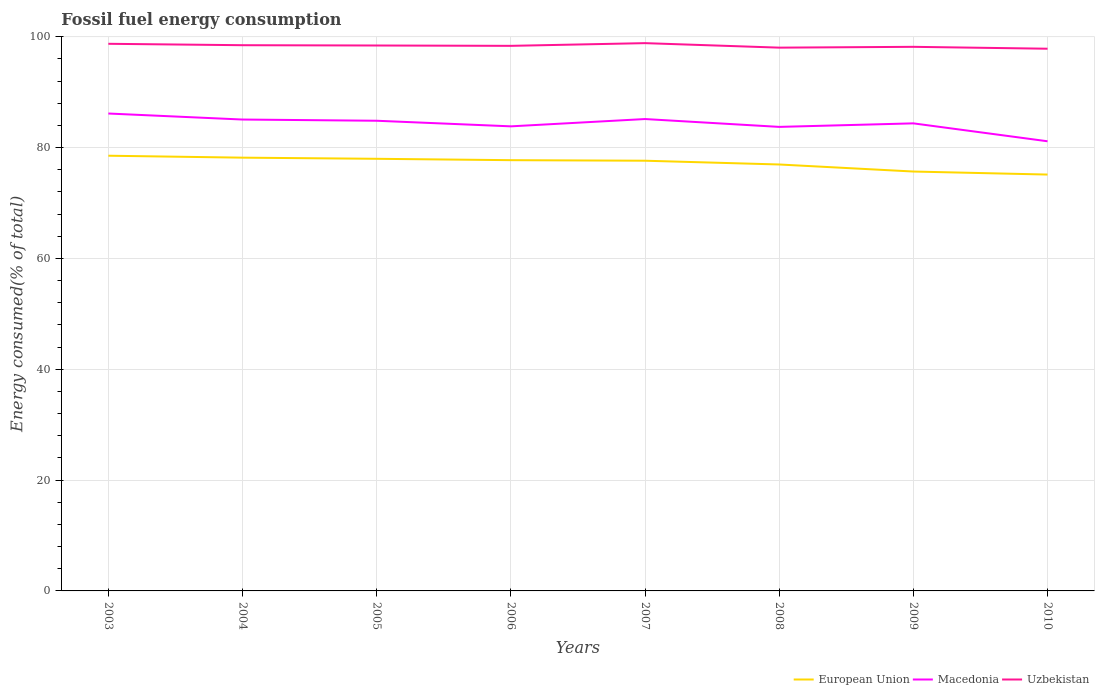How many different coloured lines are there?
Offer a very short reply. 3. Does the line corresponding to European Union intersect with the line corresponding to Uzbekistan?
Provide a succinct answer. No. Across all years, what is the maximum percentage of energy consumed in European Union?
Keep it short and to the point. 75.14. In which year was the percentage of energy consumed in European Union maximum?
Offer a very short reply. 2010. What is the total percentage of energy consumed in European Union in the graph?
Make the answer very short. 2.51. What is the difference between the highest and the second highest percentage of energy consumed in Macedonia?
Your response must be concise. 5.01. What is the difference between the highest and the lowest percentage of energy consumed in European Union?
Your response must be concise. 5. Is the percentage of energy consumed in Macedonia strictly greater than the percentage of energy consumed in European Union over the years?
Your answer should be very brief. No. How many lines are there?
Offer a very short reply. 3. What is the difference between two consecutive major ticks on the Y-axis?
Your answer should be very brief. 20. Does the graph contain grids?
Offer a terse response. Yes. How many legend labels are there?
Ensure brevity in your answer.  3. What is the title of the graph?
Your answer should be very brief. Fossil fuel energy consumption. Does "Middle income" appear as one of the legend labels in the graph?
Make the answer very short. No. What is the label or title of the Y-axis?
Keep it short and to the point. Energy consumed(% of total). What is the Energy consumed(% of total) in European Union in 2003?
Provide a short and direct response. 78.54. What is the Energy consumed(% of total) in Macedonia in 2003?
Make the answer very short. 86.15. What is the Energy consumed(% of total) in Uzbekistan in 2003?
Your answer should be compact. 98.73. What is the Energy consumed(% of total) of European Union in 2004?
Offer a very short reply. 78.19. What is the Energy consumed(% of total) of Macedonia in 2004?
Provide a succinct answer. 85.07. What is the Energy consumed(% of total) of Uzbekistan in 2004?
Your response must be concise. 98.48. What is the Energy consumed(% of total) in European Union in 2005?
Keep it short and to the point. 77.98. What is the Energy consumed(% of total) of Macedonia in 2005?
Your response must be concise. 84.85. What is the Energy consumed(% of total) in Uzbekistan in 2005?
Give a very brief answer. 98.43. What is the Energy consumed(% of total) in European Union in 2006?
Offer a terse response. 77.73. What is the Energy consumed(% of total) of Macedonia in 2006?
Keep it short and to the point. 83.84. What is the Energy consumed(% of total) in Uzbekistan in 2006?
Your response must be concise. 98.37. What is the Energy consumed(% of total) in European Union in 2007?
Ensure brevity in your answer.  77.63. What is the Energy consumed(% of total) in Macedonia in 2007?
Your response must be concise. 85.16. What is the Energy consumed(% of total) of Uzbekistan in 2007?
Offer a terse response. 98.85. What is the Energy consumed(% of total) in European Union in 2008?
Make the answer very short. 76.95. What is the Energy consumed(% of total) in Macedonia in 2008?
Make the answer very short. 83.74. What is the Energy consumed(% of total) of Uzbekistan in 2008?
Ensure brevity in your answer.  98.04. What is the Energy consumed(% of total) in European Union in 2009?
Your answer should be very brief. 75.68. What is the Energy consumed(% of total) of Macedonia in 2009?
Offer a very short reply. 84.38. What is the Energy consumed(% of total) in Uzbekistan in 2009?
Give a very brief answer. 98.19. What is the Energy consumed(% of total) in European Union in 2010?
Make the answer very short. 75.14. What is the Energy consumed(% of total) in Macedonia in 2010?
Make the answer very short. 81.14. What is the Energy consumed(% of total) in Uzbekistan in 2010?
Keep it short and to the point. 97.84. Across all years, what is the maximum Energy consumed(% of total) of European Union?
Your answer should be compact. 78.54. Across all years, what is the maximum Energy consumed(% of total) of Macedonia?
Provide a short and direct response. 86.15. Across all years, what is the maximum Energy consumed(% of total) of Uzbekistan?
Provide a succinct answer. 98.85. Across all years, what is the minimum Energy consumed(% of total) in European Union?
Your answer should be compact. 75.14. Across all years, what is the minimum Energy consumed(% of total) in Macedonia?
Offer a very short reply. 81.14. Across all years, what is the minimum Energy consumed(% of total) in Uzbekistan?
Offer a terse response. 97.84. What is the total Energy consumed(% of total) in European Union in the graph?
Your answer should be very brief. 617.84. What is the total Energy consumed(% of total) in Macedonia in the graph?
Provide a short and direct response. 674.31. What is the total Energy consumed(% of total) of Uzbekistan in the graph?
Make the answer very short. 786.93. What is the difference between the Energy consumed(% of total) of European Union in 2003 and that in 2004?
Your answer should be very brief. 0.35. What is the difference between the Energy consumed(% of total) of Macedonia in 2003 and that in 2004?
Your response must be concise. 1.09. What is the difference between the Energy consumed(% of total) of Uzbekistan in 2003 and that in 2004?
Provide a succinct answer. 0.25. What is the difference between the Energy consumed(% of total) in European Union in 2003 and that in 2005?
Your answer should be very brief. 0.56. What is the difference between the Energy consumed(% of total) of Macedonia in 2003 and that in 2005?
Your response must be concise. 1.31. What is the difference between the Energy consumed(% of total) of Uzbekistan in 2003 and that in 2005?
Make the answer very short. 0.31. What is the difference between the Energy consumed(% of total) of European Union in 2003 and that in 2006?
Your response must be concise. 0.8. What is the difference between the Energy consumed(% of total) in Macedonia in 2003 and that in 2006?
Make the answer very short. 2.32. What is the difference between the Energy consumed(% of total) of Uzbekistan in 2003 and that in 2006?
Your answer should be very brief. 0.37. What is the difference between the Energy consumed(% of total) of European Union in 2003 and that in 2007?
Your answer should be compact. 0.9. What is the difference between the Energy consumed(% of total) of Uzbekistan in 2003 and that in 2007?
Provide a short and direct response. -0.12. What is the difference between the Energy consumed(% of total) in European Union in 2003 and that in 2008?
Your answer should be compact. 1.58. What is the difference between the Energy consumed(% of total) in Macedonia in 2003 and that in 2008?
Provide a succinct answer. 2.41. What is the difference between the Energy consumed(% of total) in Uzbekistan in 2003 and that in 2008?
Your answer should be compact. 0.69. What is the difference between the Energy consumed(% of total) of European Union in 2003 and that in 2009?
Give a very brief answer. 2.85. What is the difference between the Energy consumed(% of total) of Macedonia in 2003 and that in 2009?
Make the answer very short. 1.78. What is the difference between the Energy consumed(% of total) of Uzbekistan in 2003 and that in 2009?
Your answer should be compact. 0.54. What is the difference between the Energy consumed(% of total) of European Union in 2003 and that in 2010?
Make the answer very short. 3.4. What is the difference between the Energy consumed(% of total) in Macedonia in 2003 and that in 2010?
Offer a terse response. 5.01. What is the difference between the Energy consumed(% of total) of Uzbekistan in 2003 and that in 2010?
Ensure brevity in your answer.  0.89. What is the difference between the Energy consumed(% of total) in European Union in 2004 and that in 2005?
Offer a very short reply. 0.21. What is the difference between the Energy consumed(% of total) in Macedonia in 2004 and that in 2005?
Give a very brief answer. 0.22. What is the difference between the Energy consumed(% of total) of Uzbekistan in 2004 and that in 2005?
Your answer should be very brief. 0.05. What is the difference between the Energy consumed(% of total) in European Union in 2004 and that in 2006?
Your response must be concise. 0.45. What is the difference between the Energy consumed(% of total) of Macedonia in 2004 and that in 2006?
Your response must be concise. 1.23. What is the difference between the Energy consumed(% of total) of Uzbekistan in 2004 and that in 2006?
Offer a terse response. 0.11. What is the difference between the Energy consumed(% of total) of European Union in 2004 and that in 2007?
Keep it short and to the point. 0.55. What is the difference between the Energy consumed(% of total) of Macedonia in 2004 and that in 2007?
Keep it short and to the point. -0.09. What is the difference between the Energy consumed(% of total) in Uzbekistan in 2004 and that in 2007?
Provide a short and direct response. -0.37. What is the difference between the Energy consumed(% of total) in European Union in 2004 and that in 2008?
Your answer should be very brief. 1.23. What is the difference between the Energy consumed(% of total) in Macedonia in 2004 and that in 2008?
Ensure brevity in your answer.  1.33. What is the difference between the Energy consumed(% of total) in Uzbekistan in 2004 and that in 2008?
Make the answer very short. 0.44. What is the difference between the Energy consumed(% of total) in European Union in 2004 and that in 2009?
Your answer should be very brief. 2.51. What is the difference between the Energy consumed(% of total) of Macedonia in 2004 and that in 2009?
Provide a succinct answer. 0.69. What is the difference between the Energy consumed(% of total) of Uzbekistan in 2004 and that in 2009?
Offer a very short reply. 0.29. What is the difference between the Energy consumed(% of total) in European Union in 2004 and that in 2010?
Make the answer very short. 3.05. What is the difference between the Energy consumed(% of total) of Macedonia in 2004 and that in 2010?
Your answer should be compact. 3.92. What is the difference between the Energy consumed(% of total) in Uzbekistan in 2004 and that in 2010?
Provide a short and direct response. 0.63. What is the difference between the Energy consumed(% of total) of European Union in 2005 and that in 2006?
Your answer should be very brief. 0.25. What is the difference between the Energy consumed(% of total) of Uzbekistan in 2005 and that in 2006?
Your answer should be very brief. 0.06. What is the difference between the Energy consumed(% of total) of European Union in 2005 and that in 2007?
Provide a short and direct response. 0.34. What is the difference between the Energy consumed(% of total) in Macedonia in 2005 and that in 2007?
Provide a succinct answer. -0.31. What is the difference between the Energy consumed(% of total) in Uzbekistan in 2005 and that in 2007?
Provide a succinct answer. -0.42. What is the difference between the Energy consumed(% of total) in European Union in 2005 and that in 2008?
Your response must be concise. 1.03. What is the difference between the Energy consumed(% of total) in Macedonia in 2005 and that in 2008?
Your answer should be very brief. 1.11. What is the difference between the Energy consumed(% of total) in Uzbekistan in 2005 and that in 2008?
Your response must be concise. 0.39. What is the difference between the Energy consumed(% of total) of European Union in 2005 and that in 2009?
Offer a very short reply. 2.3. What is the difference between the Energy consumed(% of total) in Macedonia in 2005 and that in 2009?
Provide a succinct answer. 0.47. What is the difference between the Energy consumed(% of total) in Uzbekistan in 2005 and that in 2009?
Offer a terse response. 0.24. What is the difference between the Energy consumed(% of total) of European Union in 2005 and that in 2010?
Make the answer very short. 2.84. What is the difference between the Energy consumed(% of total) in Macedonia in 2005 and that in 2010?
Ensure brevity in your answer.  3.7. What is the difference between the Energy consumed(% of total) in Uzbekistan in 2005 and that in 2010?
Your answer should be very brief. 0.58. What is the difference between the Energy consumed(% of total) in European Union in 2006 and that in 2007?
Your answer should be very brief. 0.1. What is the difference between the Energy consumed(% of total) of Macedonia in 2006 and that in 2007?
Offer a very short reply. -1.32. What is the difference between the Energy consumed(% of total) of Uzbekistan in 2006 and that in 2007?
Offer a terse response. -0.49. What is the difference between the Energy consumed(% of total) of European Union in 2006 and that in 2008?
Offer a terse response. 0.78. What is the difference between the Energy consumed(% of total) in Macedonia in 2006 and that in 2008?
Offer a very short reply. 0.1. What is the difference between the Energy consumed(% of total) of Uzbekistan in 2006 and that in 2008?
Ensure brevity in your answer.  0.33. What is the difference between the Energy consumed(% of total) in European Union in 2006 and that in 2009?
Give a very brief answer. 2.05. What is the difference between the Energy consumed(% of total) in Macedonia in 2006 and that in 2009?
Make the answer very short. -0.54. What is the difference between the Energy consumed(% of total) of Uzbekistan in 2006 and that in 2009?
Provide a short and direct response. 0.18. What is the difference between the Energy consumed(% of total) in European Union in 2006 and that in 2010?
Provide a short and direct response. 2.6. What is the difference between the Energy consumed(% of total) of Macedonia in 2006 and that in 2010?
Offer a terse response. 2.69. What is the difference between the Energy consumed(% of total) in Uzbekistan in 2006 and that in 2010?
Make the answer very short. 0.52. What is the difference between the Energy consumed(% of total) of European Union in 2007 and that in 2008?
Make the answer very short. 0.68. What is the difference between the Energy consumed(% of total) of Macedonia in 2007 and that in 2008?
Keep it short and to the point. 1.42. What is the difference between the Energy consumed(% of total) of Uzbekistan in 2007 and that in 2008?
Provide a short and direct response. 0.81. What is the difference between the Energy consumed(% of total) in European Union in 2007 and that in 2009?
Keep it short and to the point. 1.95. What is the difference between the Energy consumed(% of total) of Macedonia in 2007 and that in 2009?
Keep it short and to the point. 0.78. What is the difference between the Energy consumed(% of total) of Uzbekistan in 2007 and that in 2009?
Your response must be concise. 0.66. What is the difference between the Energy consumed(% of total) in European Union in 2007 and that in 2010?
Your response must be concise. 2.5. What is the difference between the Energy consumed(% of total) in Macedonia in 2007 and that in 2010?
Your answer should be compact. 4.01. What is the difference between the Energy consumed(% of total) of Uzbekistan in 2007 and that in 2010?
Your response must be concise. 1.01. What is the difference between the Energy consumed(% of total) in European Union in 2008 and that in 2009?
Ensure brevity in your answer.  1.27. What is the difference between the Energy consumed(% of total) of Macedonia in 2008 and that in 2009?
Provide a succinct answer. -0.64. What is the difference between the Energy consumed(% of total) of Uzbekistan in 2008 and that in 2009?
Make the answer very short. -0.15. What is the difference between the Energy consumed(% of total) in European Union in 2008 and that in 2010?
Offer a very short reply. 1.82. What is the difference between the Energy consumed(% of total) in Macedonia in 2008 and that in 2010?
Your answer should be very brief. 2.6. What is the difference between the Energy consumed(% of total) of Uzbekistan in 2008 and that in 2010?
Make the answer very short. 0.2. What is the difference between the Energy consumed(% of total) in European Union in 2009 and that in 2010?
Give a very brief answer. 0.55. What is the difference between the Energy consumed(% of total) in Macedonia in 2009 and that in 2010?
Your answer should be compact. 3.23. What is the difference between the Energy consumed(% of total) of Uzbekistan in 2009 and that in 2010?
Your response must be concise. 0.34. What is the difference between the Energy consumed(% of total) of European Union in 2003 and the Energy consumed(% of total) of Macedonia in 2004?
Offer a terse response. -6.53. What is the difference between the Energy consumed(% of total) of European Union in 2003 and the Energy consumed(% of total) of Uzbekistan in 2004?
Offer a terse response. -19.94. What is the difference between the Energy consumed(% of total) in Macedonia in 2003 and the Energy consumed(% of total) in Uzbekistan in 2004?
Offer a very short reply. -12.33. What is the difference between the Energy consumed(% of total) in European Union in 2003 and the Energy consumed(% of total) in Macedonia in 2005?
Your answer should be compact. -6.31. What is the difference between the Energy consumed(% of total) of European Union in 2003 and the Energy consumed(% of total) of Uzbekistan in 2005?
Offer a very short reply. -19.89. What is the difference between the Energy consumed(% of total) in Macedonia in 2003 and the Energy consumed(% of total) in Uzbekistan in 2005?
Offer a terse response. -12.28. What is the difference between the Energy consumed(% of total) of European Union in 2003 and the Energy consumed(% of total) of Macedonia in 2006?
Offer a terse response. -5.3. What is the difference between the Energy consumed(% of total) in European Union in 2003 and the Energy consumed(% of total) in Uzbekistan in 2006?
Your answer should be very brief. -19.83. What is the difference between the Energy consumed(% of total) in Macedonia in 2003 and the Energy consumed(% of total) in Uzbekistan in 2006?
Offer a terse response. -12.21. What is the difference between the Energy consumed(% of total) of European Union in 2003 and the Energy consumed(% of total) of Macedonia in 2007?
Your answer should be very brief. -6.62. What is the difference between the Energy consumed(% of total) in European Union in 2003 and the Energy consumed(% of total) in Uzbekistan in 2007?
Your answer should be compact. -20.32. What is the difference between the Energy consumed(% of total) in Macedonia in 2003 and the Energy consumed(% of total) in Uzbekistan in 2007?
Provide a short and direct response. -12.7. What is the difference between the Energy consumed(% of total) in European Union in 2003 and the Energy consumed(% of total) in Macedonia in 2008?
Offer a terse response. -5.2. What is the difference between the Energy consumed(% of total) in European Union in 2003 and the Energy consumed(% of total) in Uzbekistan in 2008?
Provide a short and direct response. -19.5. What is the difference between the Energy consumed(% of total) of Macedonia in 2003 and the Energy consumed(% of total) of Uzbekistan in 2008?
Make the answer very short. -11.89. What is the difference between the Energy consumed(% of total) in European Union in 2003 and the Energy consumed(% of total) in Macedonia in 2009?
Your response must be concise. -5.84. What is the difference between the Energy consumed(% of total) of European Union in 2003 and the Energy consumed(% of total) of Uzbekistan in 2009?
Provide a short and direct response. -19.65. What is the difference between the Energy consumed(% of total) in Macedonia in 2003 and the Energy consumed(% of total) in Uzbekistan in 2009?
Ensure brevity in your answer.  -12.04. What is the difference between the Energy consumed(% of total) in European Union in 2003 and the Energy consumed(% of total) in Macedonia in 2010?
Make the answer very short. -2.61. What is the difference between the Energy consumed(% of total) of European Union in 2003 and the Energy consumed(% of total) of Uzbekistan in 2010?
Give a very brief answer. -19.31. What is the difference between the Energy consumed(% of total) in Macedonia in 2003 and the Energy consumed(% of total) in Uzbekistan in 2010?
Offer a terse response. -11.69. What is the difference between the Energy consumed(% of total) in European Union in 2004 and the Energy consumed(% of total) in Macedonia in 2005?
Offer a terse response. -6.66. What is the difference between the Energy consumed(% of total) in European Union in 2004 and the Energy consumed(% of total) in Uzbekistan in 2005?
Make the answer very short. -20.24. What is the difference between the Energy consumed(% of total) of Macedonia in 2004 and the Energy consumed(% of total) of Uzbekistan in 2005?
Provide a short and direct response. -13.36. What is the difference between the Energy consumed(% of total) of European Union in 2004 and the Energy consumed(% of total) of Macedonia in 2006?
Your answer should be compact. -5.65. What is the difference between the Energy consumed(% of total) in European Union in 2004 and the Energy consumed(% of total) in Uzbekistan in 2006?
Provide a succinct answer. -20.18. What is the difference between the Energy consumed(% of total) of Macedonia in 2004 and the Energy consumed(% of total) of Uzbekistan in 2006?
Provide a succinct answer. -13.3. What is the difference between the Energy consumed(% of total) of European Union in 2004 and the Energy consumed(% of total) of Macedonia in 2007?
Make the answer very short. -6.97. What is the difference between the Energy consumed(% of total) in European Union in 2004 and the Energy consumed(% of total) in Uzbekistan in 2007?
Provide a succinct answer. -20.66. What is the difference between the Energy consumed(% of total) in Macedonia in 2004 and the Energy consumed(% of total) in Uzbekistan in 2007?
Provide a succinct answer. -13.79. What is the difference between the Energy consumed(% of total) in European Union in 2004 and the Energy consumed(% of total) in Macedonia in 2008?
Provide a succinct answer. -5.55. What is the difference between the Energy consumed(% of total) in European Union in 2004 and the Energy consumed(% of total) in Uzbekistan in 2008?
Provide a short and direct response. -19.85. What is the difference between the Energy consumed(% of total) in Macedonia in 2004 and the Energy consumed(% of total) in Uzbekistan in 2008?
Your response must be concise. -12.97. What is the difference between the Energy consumed(% of total) in European Union in 2004 and the Energy consumed(% of total) in Macedonia in 2009?
Your response must be concise. -6.19. What is the difference between the Energy consumed(% of total) of European Union in 2004 and the Energy consumed(% of total) of Uzbekistan in 2009?
Ensure brevity in your answer.  -20. What is the difference between the Energy consumed(% of total) in Macedonia in 2004 and the Energy consumed(% of total) in Uzbekistan in 2009?
Make the answer very short. -13.12. What is the difference between the Energy consumed(% of total) in European Union in 2004 and the Energy consumed(% of total) in Macedonia in 2010?
Make the answer very short. -2.95. What is the difference between the Energy consumed(% of total) of European Union in 2004 and the Energy consumed(% of total) of Uzbekistan in 2010?
Offer a terse response. -19.66. What is the difference between the Energy consumed(% of total) of Macedonia in 2004 and the Energy consumed(% of total) of Uzbekistan in 2010?
Ensure brevity in your answer.  -12.78. What is the difference between the Energy consumed(% of total) in European Union in 2005 and the Energy consumed(% of total) in Macedonia in 2006?
Your answer should be compact. -5.86. What is the difference between the Energy consumed(% of total) in European Union in 2005 and the Energy consumed(% of total) in Uzbekistan in 2006?
Give a very brief answer. -20.39. What is the difference between the Energy consumed(% of total) in Macedonia in 2005 and the Energy consumed(% of total) in Uzbekistan in 2006?
Your answer should be compact. -13.52. What is the difference between the Energy consumed(% of total) in European Union in 2005 and the Energy consumed(% of total) in Macedonia in 2007?
Provide a succinct answer. -7.18. What is the difference between the Energy consumed(% of total) of European Union in 2005 and the Energy consumed(% of total) of Uzbekistan in 2007?
Offer a terse response. -20.87. What is the difference between the Energy consumed(% of total) in Macedonia in 2005 and the Energy consumed(% of total) in Uzbekistan in 2007?
Your answer should be compact. -14. What is the difference between the Energy consumed(% of total) of European Union in 2005 and the Energy consumed(% of total) of Macedonia in 2008?
Provide a short and direct response. -5.76. What is the difference between the Energy consumed(% of total) of European Union in 2005 and the Energy consumed(% of total) of Uzbekistan in 2008?
Keep it short and to the point. -20.06. What is the difference between the Energy consumed(% of total) in Macedonia in 2005 and the Energy consumed(% of total) in Uzbekistan in 2008?
Provide a succinct answer. -13.19. What is the difference between the Energy consumed(% of total) of European Union in 2005 and the Energy consumed(% of total) of Macedonia in 2009?
Ensure brevity in your answer.  -6.4. What is the difference between the Energy consumed(% of total) of European Union in 2005 and the Energy consumed(% of total) of Uzbekistan in 2009?
Offer a very short reply. -20.21. What is the difference between the Energy consumed(% of total) in Macedonia in 2005 and the Energy consumed(% of total) in Uzbekistan in 2009?
Offer a terse response. -13.34. What is the difference between the Energy consumed(% of total) in European Union in 2005 and the Energy consumed(% of total) in Macedonia in 2010?
Make the answer very short. -3.16. What is the difference between the Energy consumed(% of total) of European Union in 2005 and the Energy consumed(% of total) of Uzbekistan in 2010?
Keep it short and to the point. -19.86. What is the difference between the Energy consumed(% of total) in Macedonia in 2005 and the Energy consumed(% of total) in Uzbekistan in 2010?
Make the answer very short. -13. What is the difference between the Energy consumed(% of total) of European Union in 2006 and the Energy consumed(% of total) of Macedonia in 2007?
Ensure brevity in your answer.  -7.42. What is the difference between the Energy consumed(% of total) of European Union in 2006 and the Energy consumed(% of total) of Uzbekistan in 2007?
Your answer should be very brief. -21.12. What is the difference between the Energy consumed(% of total) in Macedonia in 2006 and the Energy consumed(% of total) in Uzbekistan in 2007?
Your response must be concise. -15.02. What is the difference between the Energy consumed(% of total) in European Union in 2006 and the Energy consumed(% of total) in Macedonia in 2008?
Your answer should be compact. -6. What is the difference between the Energy consumed(% of total) of European Union in 2006 and the Energy consumed(% of total) of Uzbekistan in 2008?
Your response must be concise. -20.31. What is the difference between the Energy consumed(% of total) of Macedonia in 2006 and the Energy consumed(% of total) of Uzbekistan in 2008?
Provide a short and direct response. -14.2. What is the difference between the Energy consumed(% of total) in European Union in 2006 and the Energy consumed(% of total) in Macedonia in 2009?
Provide a short and direct response. -6.64. What is the difference between the Energy consumed(% of total) of European Union in 2006 and the Energy consumed(% of total) of Uzbekistan in 2009?
Provide a succinct answer. -20.45. What is the difference between the Energy consumed(% of total) of Macedonia in 2006 and the Energy consumed(% of total) of Uzbekistan in 2009?
Offer a terse response. -14.35. What is the difference between the Energy consumed(% of total) of European Union in 2006 and the Energy consumed(% of total) of Macedonia in 2010?
Your response must be concise. -3.41. What is the difference between the Energy consumed(% of total) of European Union in 2006 and the Energy consumed(% of total) of Uzbekistan in 2010?
Provide a succinct answer. -20.11. What is the difference between the Energy consumed(% of total) of Macedonia in 2006 and the Energy consumed(% of total) of Uzbekistan in 2010?
Ensure brevity in your answer.  -14.01. What is the difference between the Energy consumed(% of total) in European Union in 2007 and the Energy consumed(% of total) in Macedonia in 2008?
Provide a short and direct response. -6.1. What is the difference between the Energy consumed(% of total) in European Union in 2007 and the Energy consumed(% of total) in Uzbekistan in 2008?
Provide a short and direct response. -20.4. What is the difference between the Energy consumed(% of total) in Macedonia in 2007 and the Energy consumed(% of total) in Uzbekistan in 2008?
Make the answer very short. -12.88. What is the difference between the Energy consumed(% of total) in European Union in 2007 and the Energy consumed(% of total) in Macedonia in 2009?
Offer a terse response. -6.74. What is the difference between the Energy consumed(% of total) in European Union in 2007 and the Energy consumed(% of total) in Uzbekistan in 2009?
Provide a succinct answer. -20.55. What is the difference between the Energy consumed(% of total) of Macedonia in 2007 and the Energy consumed(% of total) of Uzbekistan in 2009?
Provide a succinct answer. -13.03. What is the difference between the Energy consumed(% of total) in European Union in 2007 and the Energy consumed(% of total) in Macedonia in 2010?
Offer a very short reply. -3.51. What is the difference between the Energy consumed(% of total) of European Union in 2007 and the Energy consumed(% of total) of Uzbekistan in 2010?
Keep it short and to the point. -20.21. What is the difference between the Energy consumed(% of total) in Macedonia in 2007 and the Energy consumed(% of total) in Uzbekistan in 2010?
Make the answer very short. -12.69. What is the difference between the Energy consumed(% of total) of European Union in 2008 and the Energy consumed(% of total) of Macedonia in 2009?
Your answer should be very brief. -7.42. What is the difference between the Energy consumed(% of total) in European Union in 2008 and the Energy consumed(% of total) in Uzbekistan in 2009?
Your answer should be very brief. -21.23. What is the difference between the Energy consumed(% of total) in Macedonia in 2008 and the Energy consumed(% of total) in Uzbekistan in 2009?
Make the answer very short. -14.45. What is the difference between the Energy consumed(% of total) of European Union in 2008 and the Energy consumed(% of total) of Macedonia in 2010?
Offer a terse response. -4.19. What is the difference between the Energy consumed(% of total) of European Union in 2008 and the Energy consumed(% of total) of Uzbekistan in 2010?
Provide a succinct answer. -20.89. What is the difference between the Energy consumed(% of total) in Macedonia in 2008 and the Energy consumed(% of total) in Uzbekistan in 2010?
Keep it short and to the point. -14.11. What is the difference between the Energy consumed(% of total) of European Union in 2009 and the Energy consumed(% of total) of Macedonia in 2010?
Offer a terse response. -5.46. What is the difference between the Energy consumed(% of total) in European Union in 2009 and the Energy consumed(% of total) in Uzbekistan in 2010?
Your response must be concise. -22.16. What is the difference between the Energy consumed(% of total) in Macedonia in 2009 and the Energy consumed(% of total) in Uzbekistan in 2010?
Keep it short and to the point. -13.47. What is the average Energy consumed(% of total) of European Union per year?
Offer a terse response. 77.23. What is the average Energy consumed(% of total) of Macedonia per year?
Your answer should be very brief. 84.29. What is the average Energy consumed(% of total) of Uzbekistan per year?
Keep it short and to the point. 98.37. In the year 2003, what is the difference between the Energy consumed(% of total) of European Union and Energy consumed(% of total) of Macedonia?
Your answer should be compact. -7.62. In the year 2003, what is the difference between the Energy consumed(% of total) of European Union and Energy consumed(% of total) of Uzbekistan?
Keep it short and to the point. -20.2. In the year 2003, what is the difference between the Energy consumed(% of total) of Macedonia and Energy consumed(% of total) of Uzbekistan?
Provide a short and direct response. -12.58. In the year 2004, what is the difference between the Energy consumed(% of total) in European Union and Energy consumed(% of total) in Macedonia?
Ensure brevity in your answer.  -6.88. In the year 2004, what is the difference between the Energy consumed(% of total) in European Union and Energy consumed(% of total) in Uzbekistan?
Your response must be concise. -20.29. In the year 2004, what is the difference between the Energy consumed(% of total) in Macedonia and Energy consumed(% of total) in Uzbekistan?
Provide a short and direct response. -13.41. In the year 2005, what is the difference between the Energy consumed(% of total) in European Union and Energy consumed(% of total) in Macedonia?
Make the answer very short. -6.87. In the year 2005, what is the difference between the Energy consumed(% of total) of European Union and Energy consumed(% of total) of Uzbekistan?
Provide a short and direct response. -20.45. In the year 2005, what is the difference between the Energy consumed(% of total) of Macedonia and Energy consumed(% of total) of Uzbekistan?
Provide a succinct answer. -13.58. In the year 2006, what is the difference between the Energy consumed(% of total) in European Union and Energy consumed(% of total) in Macedonia?
Your response must be concise. -6.1. In the year 2006, what is the difference between the Energy consumed(% of total) of European Union and Energy consumed(% of total) of Uzbekistan?
Offer a terse response. -20.63. In the year 2006, what is the difference between the Energy consumed(% of total) in Macedonia and Energy consumed(% of total) in Uzbekistan?
Provide a succinct answer. -14.53. In the year 2007, what is the difference between the Energy consumed(% of total) in European Union and Energy consumed(% of total) in Macedonia?
Give a very brief answer. -7.52. In the year 2007, what is the difference between the Energy consumed(% of total) in European Union and Energy consumed(% of total) in Uzbekistan?
Ensure brevity in your answer.  -21.22. In the year 2007, what is the difference between the Energy consumed(% of total) in Macedonia and Energy consumed(% of total) in Uzbekistan?
Provide a succinct answer. -13.7. In the year 2008, what is the difference between the Energy consumed(% of total) of European Union and Energy consumed(% of total) of Macedonia?
Provide a short and direct response. -6.78. In the year 2008, what is the difference between the Energy consumed(% of total) in European Union and Energy consumed(% of total) in Uzbekistan?
Offer a terse response. -21.08. In the year 2008, what is the difference between the Energy consumed(% of total) in Macedonia and Energy consumed(% of total) in Uzbekistan?
Your answer should be very brief. -14.3. In the year 2009, what is the difference between the Energy consumed(% of total) in European Union and Energy consumed(% of total) in Macedonia?
Offer a very short reply. -8.69. In the year 2009, what is the difference between the Energy consumed(% of total) in European Union and Energy consumed(% of total) in Uzbekistan?
Provide a short and direct response. -22.51. In the year 2009, what is the difference between the Energy consumed(% of total) of Macedonia and Energy consumed(% of total) of Uzbekistan?
Provide a short and direct response. -13.81. In the year 2010, what is the difference between the Energy consumed(% of total) in European Union and Energy consumed(% of total) in Macedonia?
Offer a very short reply. -6.01. In the year 2010, what is the difference between the Energy consumed(% of total) in European Union and Energy consumed(% of total) in Uzbekistan?
Provide a short and direct response. -22.71. In the year 2010, what is the difference between the Energy consumed(% of total) of Macedonia and Energy consumed(% of total) of Uzbekistan?
Give a very brief answer. -16.7. What is the ratio of the Energy consumed(% of total) in Macedonia in 2003 to that in 2004?
Your answer should be compact. 1.01. What is the ratio of the Energy consumed(% of total) in Uzbekistan in 2003 to that in 2004?
Offer a very short reply. 1. What is the ratio of the Energy consumed(% of total) of European Union in 2003 to that in 2005?
Keep it short and to the point. 1.01. What is the ratio of the Energy consumed(% of total) of Macedonia in 2003 to that in 2005?
Make the answer very short. 1.02. What is the ratio of the Energy consumed(% of total) of European Union in 2003 to that in 2006?
Your answer should be compact. 1.01. What is the ratio of the Energy consumed(% of total) of Macedonia in 2003 to that in 2006?
Your answer should be compact. 1.03. What is the ratio of the Energy consumed(% of total) of European Union in 2003 to that in 2007?
Provide a short and direct response. 1.01. What is the ratio of the Energy consumed(% of total) of Macedonia in 2003 to that in 2007?
Offer a terse response. 1.01. What is the ratio of the Energy consumed(% of total) in European Union in 2003 to that in 2008?
Offer a very short reply. 1.02. What is the ratio of the Energy consumed(% of total) in Macedonia in 2003 to that in 2008?
Your answer should be compact. 1.03. What is the ratio of the Energy consumed(% of total) of Uzbekistan in 2003 to that in 2008?
Your answer should be very brief. 1.01. What is the ratio of the Energy consumed(% of total) in European Union in 2003 to that in 2009?
Your answer should be very brief. 1.04. What is the ratio of the Energy consumed(% of total) of Uzbekistan in 2003 to that in 2009?
Provide a succinct answer. 1.01. What is the ratio of the Energy consumed(% of total) in European Union in 2003 to that in 2010?
Your answer should be compact. 1.05. What is the ratio of the Energy consumed(% of total) in Macedonia in 2003 to that in 2010?
Give a very brief answer. 1.06. What is the ratio of the Energy consumed(% of total) in Uzbekistan in 2003 to that in 2010?
Give a very brief answer. 1.01. What is the ratio of the Energy consumed(% of total) of European Union in 2004 to that in 2005?
Make the answer very short. 1. What is the ratio of the Energy consumed(% of total) of Macedonia in 2004 to that in 2005?
Your answer should be very brief. 1. What is the ratio of the Energy consumed(% of total) in Uzbekistan in 2004 to that in 2005?
Your answer should be very brief. 1. What is the ratio of the Energy consumed(% of total) in Macedonia in 2004 to that in 2006?
Your response must be concise. 1.01. What is the ratio of the Energy consumed(% of total) of Uzbekistan in 2004 to that in 2006?
Offer a terse response. 1. What is the ratio of the Energy consumed(% of total) of European Union in 2004 to that in 2007?
Provide a short and direct response. 1.01. What is the ratio of the Energy consumed(% of total) in Uzbekistan in 2004 to that in 2007?
Provide a short and direct response. 1. What is the ratio of the Energy consumed(% of total) of Macedonia in 2004 to that in 2008?
Provide a short and direct response. 1.02. What is the ratio of the Energy consumed(% of total) in European Union in 2004 to that in 2009?
Offer a terse response. 1.03. What is the ratio of the Energy consumed(% of total) of Macedonia in 2004 to that in 2009?
Offer a very short reply. 1.01. What is the ratio of the Energy consumed(% of total) of Uzbekistan in 2004 to that in 2009?
Make the answer very short. 1. What is the ratio of the Energy consumed(% of total) in European Union in 2004 to that in 2010?
Give a very brief answer. 1.04. What is the ratio of the Energy consumed(% of total) in Macedonia in 2004 to that in 2010?
Provide a succinct answer. 1.05. What is the ratio of the Energy consumed(% of total) in Uzbekistan in 2004 to that in 2010?
Make the answer very short. 1.01. What is the ratio of the Energy consumed(% of total) in Macedonia in 2005 to that in 2006?
Offer a terse response. 1.01. What is the ratio of the Energy consumed(% of total) in Uzbekistan in 2005 to that in 2006?
Ensure brevity in your answer.  1. What is the ratio of the Energy consumed(% of total) of Macedonia in 2005 to that in 2007?
Ensure brevity in your answer.  1. What is the ratio of the Energy consumed(% of total) in European Union in 2005 to that in 2008?
Offer a very short reply. 1.01. What is the ratio of the Energy consumed(% of total) in Macedonia in 2005 to that in 2008?
Make the answer very short. 1.01. What is the ratio of the Energy consumed(% of total) in European Union in 2005 to that in 2009?
Make the answer very short. 1.03. What is the ratio of the Energy consumed(% of total) in Macedonia in 2005 to that in 2009?
Make the answer very short. 1.01. What is the ratio of the Energy consumed(% of total) of Uzbekistan in 2005 to that in 2009?
Keep it short and to the point. 1. What is the ratio of the Energy consumed(% of total) in European Union in 2005 to that in 2010?
Offer a very short reply. 1.04. What is the ratio of the Energy consumed(% of total) in Macedonia in 2005 to that in 2010?
Keep it short and to the point. 1.05. What is the ratio of the Energy consumed(% of total) of Uzbekistan in 2005 to that in 2010?
Your answer should be compact. 1.01. What is the ratio of the Energy consumed(% of total) in Macedonia in 2006 to that in 2007?
Make the answer very short. 0.98. What is the ratio of the Energy consumed(% of total) of Uzbekistan in 2006 to that in 2007?
Keep it short and to the point. 1. What is the ratio of the Energy consumed(% of total) of Uzbekistan in 2006 to that in 2008?
Provide a succinct answer. 1. What is the ratio of the Energy consumed(% of total) of European Union in 2006 to that in 2009?
Your response must be concise. 1.03. What is the ratio of the Energy consumed(% of total) in European Union in 2006 to that in 2010?
Ensure brevity in your answer.  1.03. What is the ratio of the Energy consumed(% of total) in Macedonia in 2006 to that in 2010?
Your response must be concise. 1.03. What is the ratio of the Energy consumed(% of total) in European Union in 2007 to that in 2008?
Give a very brief answer. 1.01. What is the ratio of the Energy consumed(% of total) of Macedonia in 2007 to that in 2008?
Provide a succinct answer. 1.02. What is the ratio of the Energy consumed(% of total) in Uzbekistan in 2007 to that in 2008?
Provide a succinct answer. 1.01. What is the ratio of the Energy consumed(% of total) of European Union in 2007 to that in 2009?
Provide a short and direct response. 1.03. What is the ratio of the Energy consumed(% of total) of Macedonia in 2007 to that in 2009?
Offer a terse response. 1.01. What is the ratio of the Energy consumed(% of total) in Uzbekistan in 2007 to that in 2009?
Offer a terse response. 1.01. What is the ratio of the Energy consumed(% of total) of European Union in 2007 to that in 2010?
Offer a terse response. 1.03. What is the ratio of the Energy consumed(% of total) in Macedonia in 2007 to that in 2010?
Offer a terse response. 1.05. What is the ratio of the Energy consumed(% of total) of Uzbekistan in 2007 to that in 2010?
Provide a short and direct response. 1.01. What is the ratio of the Energy consumed(% of total) of European Union in 2008 to that in 2009?
Keep it short and to the point. 1.02. What is the ratio of the Energy consumed(% of total) of Macedonia in 2008 to that in 2009?
Make the answer very short. 0.99. What is the ratio of the Energy consumed(% of total) in Uzbekistan in 2008 to that in 2009?
Provide a succinct answer. 1. What is the ratio of the Energy consumed(% of total) of European Union in 2008 to that in 2010?
Your answer should be compact. 1.02. What is the ratio of the Energy consumed(% of total) in Macedonia in 2008 to that in 2010?
Provide a succinct answer. 1.03. What is the ratio of the Energy consumed(% of total) of European Union in 2009 to that in 2010?
Give a very brief answer. 1.01. What is the ratio of the Energy consumed(% of total) in Macedonia in 2009 to that in 2010?
Offer a very short reply. 1.04. What is the ratio of the Energy consumed(% of total) of Uzbekistan in 2009 to that in 2010?
Your response must be concise. 1. What is the difference between the highest and the second highest Energy consumed(% of total) in European Union?
Ensure brevity in your answer.  0.35. What is the difference between the highest and the second highest Energy consumed(% of total) in Macedonia?
Your answer should be very brief. 1. What is the difference between the highest and the second highest Energy consumed(% of total) of Uzbekistan?
Provide a short and direct response. 0.12. What is the difference between the highest and the lowest Energy consumed(% of total) of European Union?
Keep it short and to the point. 3.4. What is the difference between the highest and the lowest Energy consumed(% of total) in Macedonia?
Make the answer very short. 5.01. What is the difference between the highest and the lowest Energy consumed(% of total) of Uzbekistan?
Your answer should be very brief. 1.01. 